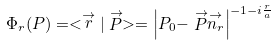Convert formula to latex. <formula><loc_0><loc_0><loc_500><loc_500>\Phi _ { r } ( P ) = < \stackrel { \rightarrow } { r } | \stackrel { \rightarrow } { P } > = \left | P _ { 0 } - \stackrel { \rightarrow } { P } \stackrel { \rightarrow } { n _ { r } } \right | ^ { - 1 - i \frac { r } { a } }</formula> 